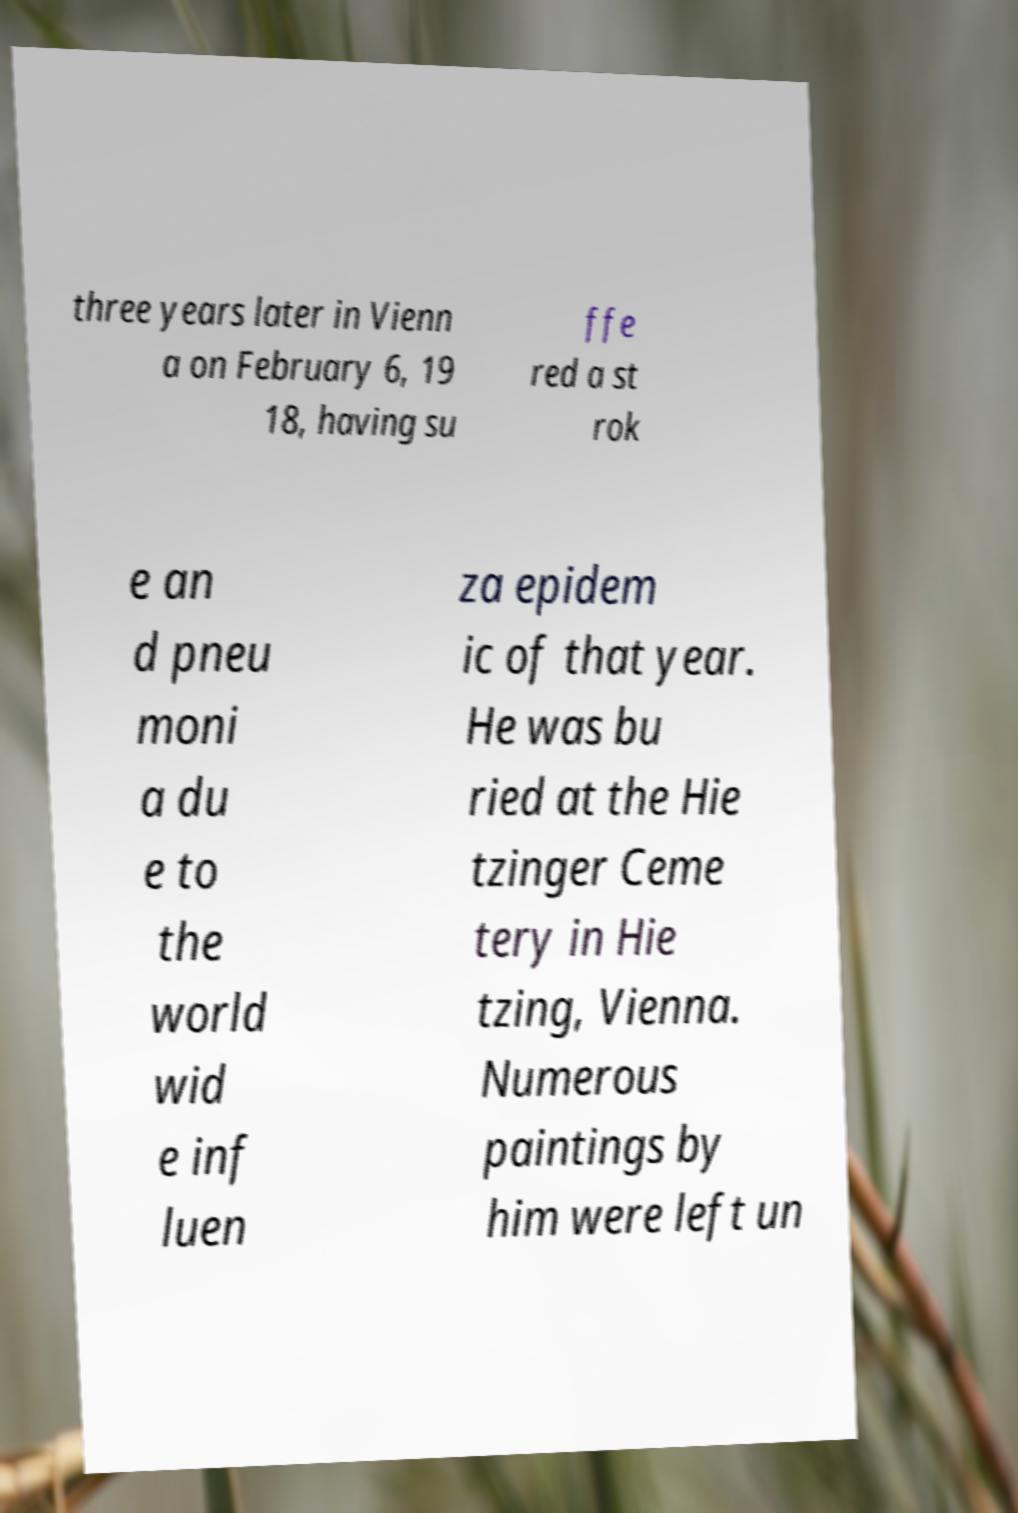Please read and relay the text visible in this image. What does it say? three years later in Vienn a on February 6, 19 18, having su ffe red a st rok e an d pneu moni a du e to the world wid e inf luen za epidem ic of that year. He was bu ried at the Hie tzinger Ceme tery in Hie tzing, Vienna. Numerous paintings by him were left un 